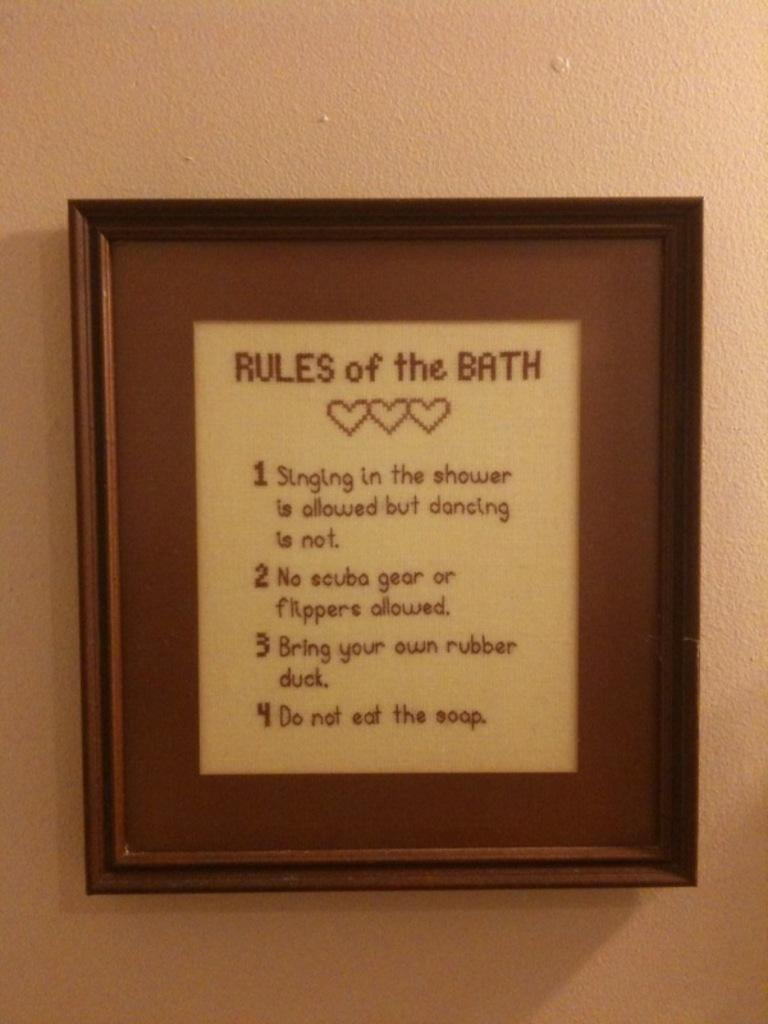Provide a one-sentence caption for the provided image. a print of "rules of the bath", including "Do not eat the soap". 